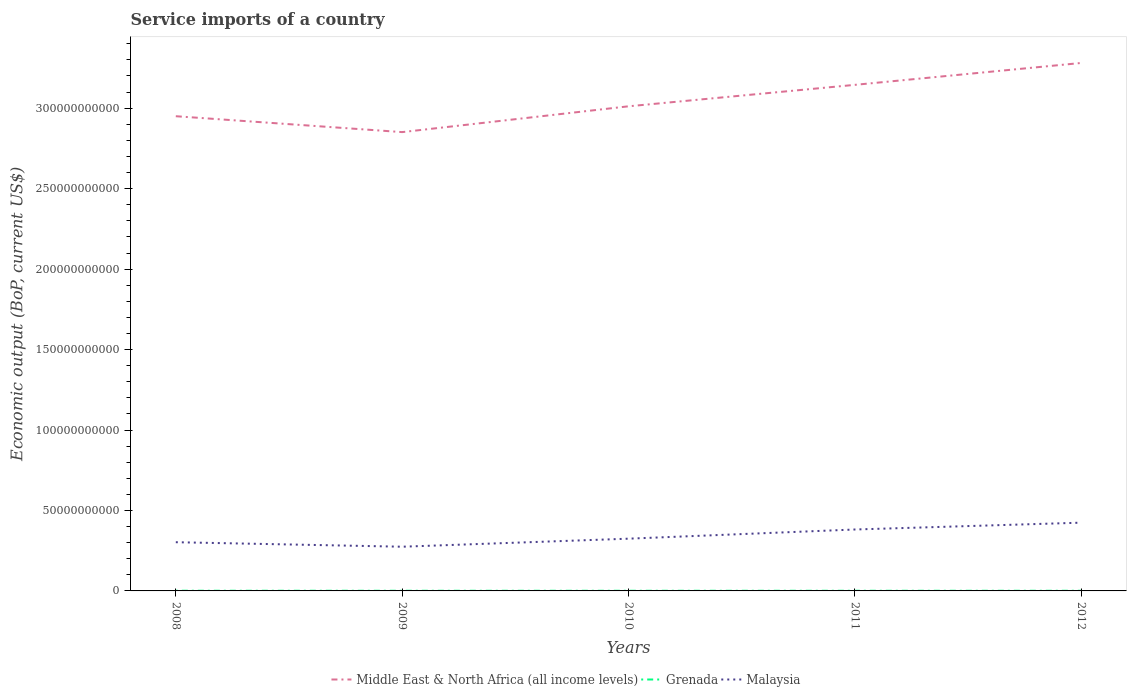Does the line corresponding to Malaysia intersect with the line corresponding to Grenada?
Give a very brief answer. No. Across all years, what is the maximum service imports in Grenada?
Offer a very short reply. 9.40e+07. What is the total service imports in Malaysia in the graph?
Offer a terse response. -1.49e+1. What is the difference between the highest and the second highest service imports in Malaysia?
Provide a succinct answer. 1.49e+1. What is the difference between the highest and the lowest service imports in Grenada?
Ensure brevity in your answer.  2. How many lines are there?
Keep it short and to the point. 3. Are the values on the major ticks of Y-axis written in scientific E-notation?
Make the answer very short. No. Does the graph contain any zero values?
Your answer should be very brief. No. Does the graph contain grids?
Provide a succinct answer. No. Where does the legend appear in the graph?
Ensure brevity in your answer.  Bottom center. What is the title of the graph?
Provide a succinct answer. Service imports of a country. Does "Japan" appear as one of the legend labels in the graph?
Offer a very short reply. No. What is the label or title of the Y-axis?
Make the answer very short. Economic output (BoP, current US$). What is the Economic output (BoP, current US$) of Middle East & North Africa (all income levels) in 2008?
Give a very brief answer. 2.95e+11. What is the Economic output (BoP, current US$) in Grenada in 2008?
Keep it short and to the point. 1.13e+08. What is the Economic output (BoP, current US$) of Malaysia in 2008?
Your answer should be compact. 3.03e+1. What is the Economic output (BoP, current US$) in Middle East & North Africa (all income levels) in 2009?
Ensure brevity in your answer.  2.85e+11. What is the Economic output (BoP, current US$) in Grenada in 2009?
Your response must be concise. 9.81e+07. What is the Economic output (BoP, current US$) in Malaysia in 2009?
Your answer should be compact. 2.75e+1. What is the Economic output (BoP, current US$) in Middle East & North Africa (all income levels) in 2010?
Give a very brief answer. 3.01e+11. What is the Economic output (BoP, current US$) in Grenada in 2010?
Provide a succinct answer. 9.40e+07. What is the Economic output (BoP, current US$) of Malaysia in 2010?
Keep it short and to the point. 3.25e+1. What is the Economic output (BoP, current US$) in Middle East & North Africa (all income levels) in 2011?
Offer a terse response. 3.15e+11. What is the Economic output (BoP, current US$) in Grenada in 2011?
Provide a succinct answer. 1.00e+08. What is the Economic output (BoP, current US$) in Malaysia in 2011?
Keep it short and to the point. 3.82e+1. What is the Economic output (BoP, current US$) of Middle East & North Africa (all income levels) in 2012?
Ensure brevity in your answer.  3.28e+11. What is the Economic output (BoP, current US$) in Grenada in 2012?
Your answer should be compact. 9.54e+07. What is the Economic output (BoP, current US$) of Malaysia in 2012?
Give a very brief answer. 4.24e+1. Across all years, what is the maximum Economic output (BoP, current US$) of Middle East & North Africa (all income levels)?
Your answer should be very brief. 3.28e+11. Across all years, what is the maximum Economic output (BoP, current US$) of Grenada?
Your answer should be compact. 1.13e+08. Across all years, what is the maximum Economic output (BoP, current US$) in Malaysia?
Your answer should be compact. 4.24e+1. Across all years, what is the minimum Economic output (BoP, current US$) in Middle East & North Africa (all income levels)?
Your answer should be very brief. 2.85e+11. Across all years, what is the minimum Economic output (BoP, current US$) in Grenada?
Provide a succinct answer. 9.40e+07. Across all years, what is the minimum Economic output (BoP, current US$) of Malaysia?
Offer a terse response. 2.75e+1. What is the total Economic output (BoP, current US$) in Middle East & North Africa (all income levels) in the graph?
Give a very brief answer. 1.52e+12. What is the total Economic output (BoP, current US$) in Grenada in the graph?
Offer a terse response. 5.01e+08. What is the total Economic output (BoP, current US$) of Malaysia in the graph?
Your response must be concise. 1.71e+11. What is the difference between the Economic output (BoP, current US$) of Middle East & North Africa (all income levels) in 2008 and that in 2009?
Give a very brief answer. 9.87e+09. What is the difference between the Economic output (BoP, current US$) of Grenada in 2008 and that in 2009?
Offer a very short reply. 1.49e+07. What is the difference between the Economic output (BoP, current US$) in Malaysia in 2008 and that in 2009?
Give a very brief answer. 2.80e+09. What is the difference between the Economic output (BoP, current US$) in Middle East & North Africa (all income levels) in 2008 and that in 2010?
Ensure brevity in your answer.  -6.16e+09. What is the difference between the Economic output (BoP, current US$) of Grenada in 2008 and that in 2010?
Give a very brief answer. 1.90e+07. What is the difference between the Economic output (BoP, current US$) in Malaysia in 2008 and that in 2010?
Your answer should be very brief. -2.20e+09. What is the difference between the Economic output (BoP, current US$) in Middle East & North Africa (all income levels) in 2008 and that in 2011?
Ensure brevity in your answer.  -1.95e+1. What is the difference between the Economic output (BoP, current US$) in Grenada in 2008 and that in 2011?
Provide a short and direct response. 1.28e+07. What is the difference between the Economic output (BoP, current US$) of Malaysia in 2008 and that in 2011?
Make the answer very short. -7.90e+09. What is the difference between the Economic output (BoP, current US$) in Middle East & North Africa (all income levels) in 2008 and that in 2012?
Make the answer very short. -3.31e+1. What is the difference between the Economic output (BoP, current US$) of Grenada in 2008 and that in 2012?
Provide a succinct answer. 1.76e+07. What is the difference between the Economic output (BoP, current US$) of Malaysia in 2008 and that in 2012?
Keep it short and to the point. -1.21e+1. What is the difference between the Economic output (BoP, current US$) of Middle East & North Africa (all income levels) in 2009 and that in 2010?
Ensure brevity in your answer.  -1.60e+1. What is the difference between the Economic output (BoP, current US$) of Grenada in 2009 and that in 2010?
Provide a succinct answer. 4.11e+06. What is the difference between the Economic output (BoP, current US$) of Malaysia in 2009 and that in 2010?
Your answer should be compact. -5.00e+09. What is the difference between the Economic output (BoP, current US$) of Middle East & North Africa (all income levels) in 2009 and that in 2011?
Make the answer very short. -2.94e+1. What is the difference between the Economic output (BoP, current US$) of Grenada in 2009 and that in 2011?
Give a very brief answer. -2.10e+06. What is the difference between the Economic output (BoP, current US$) in Malaysia in 2009 and that in 2011?
Your answer should be compact. -1.07e+1. What is the difference between the Economic output (BoP, current US$) in Middle East & North Africa (all income levels) in 2009 and that in 2012?
Your answer should be very brief. -4.30e+1. What is the difference between the Economic output (BoP, current US$) of Grenada in 2009 and that in 2012?
Provide a short and direct response. 2.73e+06. What is the difference between the Economic output (BoP, current US$) of Malaysia in 2009 and that in 2012?
Ensure brevity in your answer.  -1.49e+1. What is the difference between the Economic output (BoP, current US$) of Middle East & North Africa (all income levels) in 2010 and that in 2011?
Provide a succinct answer. -1.33e+1. What is the difference between the Economic output (BoP, current US$) in Grenada in 2010 and that in 2011?
Offer a terse response. -6.20e+06. What is the difference between the Economic output (BoP, current US$) of Malaysia in 2010 and that in 2011?
Provide a short and direct response. -5.70e+09. What is the difference between the Economic output (BoP, current US$) of Middle East & North Africa (all income levels) in 2010 and that in 2012?
Provide a short and direct response. -2.69e+1. What is the difference between the Economic output (BoP, current US$) of Grenada in 2010 and that in 2012?
Ensure brevity in your answer.  -1.37e+06. What is the difference between the Economic output (BoP, current US$) of Malaysia in 2010 and that in 2012?
Keep it short and to the point. -9.95e+09. What is the difference between the Economic output (BoP, current US$) in Middle East & North Africa (all income levels) in 2011 and that in 2012?
Give a very brief answer. -1.36e+1. What is the difference between the Economic output (BoP, current US$) of Grenada in 2011 and that in 2012?
Provide a short and direct response. 4.83e+06. What is the difference between the Economic output (BoP, current US$) of Malaysia in 2011 and that in 2012?
Your answer should be very brief. -4.25e+09. What is the difference between the Economic output (BoP, current US$) of Middle East & North Africa (all income levels) in 2008 and the Economic output (BoP, current US$) of Grenada in 2009?
Ensure brevity in your answer.  2.95e+11. What is the difference between the Economic output (BoP, current US$) of Middle East & North Africa (all income levels) in 2008 and the Economic output (BoP, current US$) of Malaysia in 2009?
Give a very brief answer. 2.68e+11. What is the difference between the Economic output (BoP, current US$) in Grenada in 2008 and the Economic output (BoP, current US$) in Malaysia in 2009?
Your response must be concise. -2.74e+1. What is the difference between the Economic output (BoP, current US$) of Middle East & North Africa (all income levels) in 2008 and the Economic output (BoP, current US$) of Grenada in 2010?
Make the answer very short. 2.95e+11. What is the difference between the Economic output (BoP, current US$) in Middle East & North Africa (all income levels) in 2008 and the Economic output (BoP, current US$) in Malaysia in 2010?
Your response must be concise. 2.63e+11. What is the difference between the Economic output (BoP, current US$) of Grenada in 2008 and the Economic output (BoP, current US$) of Malaysia in 2010?
Ensure brevity in your answer.  -3.24e+1. What is the difference between the Economic output (BoP, current US$) of Middle East & North Africa (all income levels) in 2008 and the Economic output (BoP, current US$) of Grenada in 2011?
Provide a short and direct response. 2.95e+11. What is the difference between the Economic output (BoP, current US$) of Middle East & North Africa (all income levels) in 2008 and the Economic output (BoP, current US$) of Malaysia in 2011?
Your answer should be very brief. 2.57e+11. What is the difference between the Economic output (BoP, current US$) in Grenada in 2008 and the Economic output (BoP, current US$) in Malaysia in 2011?
Your response must be concise. -3.81e+1. What is the difference between the Economic output (BoP, current US$) of Middle East & North Africa (all income levels) in 2008 and the Economic output (BoP, current US$) of Grenada in 2012?
Make the answer very short. 2.95e+11. What is the difference between the Economic output (BoP, current US$) of Middle East & North Africa (all income levels) in 2008 and the Economic output (BoP, current US$) of Malaysia in 2012?
Your answer should be compact. 2.53e+11. What is the difference between the Economic output (BoP, current US$) of Grenada in 2008 and the Economic output (BoP, current US$) of Malaysia in 2012?
Give a very brief answer. -4.23e+1. What is the difference between the Economic output (BoP, current US$) of Middle East & North Africa (all income levels) in 2009 and the Economic output (BoP, current US$) of Grenada in 2010?
Your answer should be very brief. 2.85e+11. What is the difference between the Economic output (BoP, current US$) in Middle East & North Africa (all income levels) in 2009 and the Economic output (BoP, current US$) in Malaysia in 2010?
Keep it short and to the point. 2.53e+11. What is the difference between the Economic output (BoP, current US$) of Grenada in 2009 and the Economic output (BoP, current US$) of Malaysia in 2010?
Keep it short and to the point. -3.24e+1. What is the difference between the Economic output (BoP, current US$) of Middle East & North Africa (all income levels) in 2009 and the Economic output (BoP, current US$) of Grenada in 2011?
Offer a very short reply. 2.85e+11. What is the difference between the Economic output (BoP, current US$) of Middle East & North Africa (all income levels) in 2009 and the Economic output (BoP, current US$) of Malaysia in 2011?
Your answer should be compact. 2.47e+11. What is the difference between the Economic output (BoP, current US$) in Grenada in 2009 and the Economic output (BoP, current US$) in Malaysia in 2011?
Your response must be concise. -3.81e+1. What is the difference between the Economic output (BoP, current US$) in Middle East & North Africa (all income levels) in 2009 and the Economic output (BoP, current US$) in Grenada in 2012?
Provide a succinct answer. 2.85e+11. What is the difference between the Economic output (BoP, current US$) of Middle East & North Africa (all income levels) in 2009 and the Economic output (BoP, current US$) of Malaysia in 2012?
Your response must be concise. 2.43e+11. What is the difference between the Economic output (BoP, current US$) of Grenada in 2009 and the Economic output (BoP, current US$) of Malaysia in 2012?
Your answer should be very brief. -4.23e+1. What is the difference between the Economic output (BoP, current US$) in Middle East & North Africa (all income levels) in 2010 and the Economic output (BoP, current US$) in Grenada in 2011?
Your answer should be very brief. 3.01e+11. What is the difference between the Economic output (BoP, current US$) in Middle East & North Africa (all income levels) in 2010 and the Economic output (BoP, current US$) in Malaysia in 2011?
Ensure brevity in your answer.  2.63e+11. What is the difference between the Economic output (BoP, current US$) of Grenada in 2010 and the Economic output (BoP, current US$) of Malaysia in 2011?
Keep it short and to the point. -3.81e+1. What is the difference between the Economic output (BoP, current US$) of Middle East & North Africa (all income levels) in 2010 and the Economic output (BoP, current US$) of Grenada in 2012?
Your answer should be very brief. 3.01e+11. What is the difference between the Economic output (BoP, current US$) of Middle East & North Africa (all income levels) in 2010 and the Economic output (BoP, current US$) of Malaysia in 2012?
Give a very brief answer. 2.59e+11. What is the difference between the Economic output (BoP, current US$) in Grenada in 2010 and the Economic output (BoP, current US$) in Malaysia in 2012?
Ensure brevity in your answer.  -4.23e+1. What is the difference between the Economic output (BoP, current US$) in Middle East & North Africa (all income levels) in 2011 and the Economic output (BoP, current US$) in Grenada in 2012?
Give a very brief answer. 3.14e+11. What is the difference between the Economic output (BoP, current US$) in Middle East & North Africa (all income levels) in 2011 and the Economic output (BoP, current US$) in Malaysia in 2012?
Your answer should be very brief. 2.72e+11. What is the difference between the Economic output (BoP, current US$) of Grenada in 2011 and the Economic output (BoP, current US$) of Malaysia in 2012?
Ensure brevity in your answer.  -4.23e+1. What is the average Economic output (BoP, current US$) in Middle East & North Africa (all income levels) per year?
Provide a short and direct response. 3.05e+11. What is the average Economic output (BoP, current US$) in Grenada per year?
Your answer should be very brief. 1.00e+08. What is the average Economic output (BoP, current US$) in Malaysia per year?
Give a very brief answer. 3.42e+1. In the year 2008, what is the difference between the Economic output (BoP, current US$) of Middle East & North Africa (all income levels) and Economic output (BoP, current US$) of Grenada?
Keep it short and to the point. 2.95e+11. In the year 2008, what is the difference between the Economic output (BoP, current US$) in Middle East & North Africa (all income levels) and Economic output (BoP, current US$) in Malaysia?
Your answer should be very brief. 2.65e+11. In the year 2008, what is the difference between the Economic output (BoP, current US$) in Grenada and Economic output (BoP, current US$) in Malaysia?
Offer a very short reply. -3.02e+1. In the year 2009, what is the difference between the Economic output (BoP, current US$) of Middle East & North Africa (all income levels) and Economic output (BoP, current US$) of Grenada?
Your answer should be very brief. 2.85e+11. In the year 2009, what is the difference between the Economic output (BoP, current US$) of Middle East & North Africa (all income levels) and Economic output (BoP, current US$) of Malaysia?
Your answer should be very brief. 2.58e+11. In the year 2009, what is the difference between the Economic output (BoP, current US$) in Grenada and Economic output (BoP, current US$) in Malaysia?
Your answer should be very brief. -2.74e+1. In the year 2010, what is the difference between the Economic output (BoP, current US$) in Middle East & North Africa (all income levels) and Economic output (BoP, current US$) in Grenada?
Make the answer very short. 3.01e+11. In the year 2010, what is the difference between the Economic output (BoP, current US$) of Middle East & North Africa (all income levels) and Economic output (BoP, current US$) of Malaysia?
Give a very brief answer. 2.69e+11. In the year 2010, what is the difference between the Economic output (BoP, current US$) in Grenada and Economic output (BoP, current US$) in Malaysia?
Make the answer very short. -3.24e+1. In the year 2011, what is the difference between the Economic output (BoP, current US$) in Middle East & North Africa (all income levels) and Economic output (BoP, current US$) in Grenada?
Give a very brief answer. 3.14e+11. In the year 2011, what is the difference between the Economic output (BoP, current US$) of Middle East & North Africa (all income levels) and Economic output (BoP, current US$) of Malaysia?
Your answer should be compact. 2.76e+11. In the year 2011, what is the difference between the Economic output (BoP, current US$) of Grenada and Economic output (BoP, current US$) of Malaysia?
Provide a short and direct response. -3.81e+1. In the year 2012, what is the difference between the Economic output (BoP, current US$) in Middle East & North Africa (all income levels) and Economic output (BoP, current US$) in Grenada?
Your answer should be compact. 3.28e+11. In the year 2012, what is the difference between the Economic output (BoP, current US$) in Middle East & North Africa (all income levels) and Economic output (BoP, current US$) in Malaysia?
Make the answer very short. 2.86e+11. In the year 2012, what is the difference between the Economic output (BoP, current US$) of Grenada and Economic output (BoP, current US$) of Malaysia?
Keep it short and to the point. -4.23e+1. What is the ratio of the Economic output (BoP, current US$) in Middle East & North Africa (all income levels) in 2008 to that in 2009?
Offer a terse response. 1.03. What is the ratio of the Economic output (BoP, current US$) of Grenada in 2008 to that in 2009?
Offer a terse response. 1.15. What is the ratio of the Economic output (BoP, current US$) in Malaysia in 2008 to that in 2009?
Ensure brevity in your answer.  1.1. What is the ratio of the Economic output (BoP, current US$) of Middle East & North Africa (all income levels) in 2008 to that in 2010?
Make the answer very short. 0.98. What is the ratio of the Economic output (BoP, current US$) of Grenada in 2008 to that in 2010?
Ensure brevity in your answer.  1.2. What is the ratio of the Economic output (BoP, current US$) in Malaysia in 2008 to that in 2010?
Your answer should be very brief. 0.93. What is the ratio of the Economic output (BoP, current US$) of Middle East & North Africa (all income levels) in 2008 to that in 2011?
Your response must be concise. 0.94. What is the ratio of the Economic output (BoP, current US$) of Grenada in 2008 to that in 2011?
Give a very brief answer. 1.13. What is the ratio of the Economic output (BoP, current US$) in Malaysia in 2008 to that in 2011?
Keep it short and to the point. 0.79. What is the ratio of the Economic output (BoP, current US$) in Middle East & North Africa (all income levels) in 2008 to that in 2012?
Offer a very short reply. 0.9. What is the ratio of the Economic output (BoP, current US$) in Grenada in 2008 to that in 2012?
Offer a very short reply. 1.18. What is the ratio of the Economic output (BoP, current US$) of Malaysia in 2008 to that in 2012?
Provide a short and direct response. 0.71. What is the ratio of the Economic output (BoP, current US$) in Middle East & North Africa (all income levels) in 2009 to that in 2010?
Your response must be concise. 0.95. What is the ratio of the Economic output (BoP, current US$) of Grenada in 2009 to that in 2010?
Offer a terse response. 1.04. What is the ratio of the Economic output (BoP, current US$) of Malaysia in 2009 to that in 2010?
Offer a very short reply. 0.85. What is the ratio of the Economic output (BoP, current US$) of Middle East & North Africa (all income levels) in 2009 to that in 2011?
Your answer should be very brief. 0.91. What is the ratio of the Economic output (BoP, current US$) in Grenada in 2009 to that in 2011?
Give a very brief answer. 0.98. What is the ratio of the Economic output (BoP, current US$) in Malaysia in 2009 to that in 2011?
Ensure brevity in your answer.  0.72. What is the ratio of the Economic output (BoP, current US$) in Middle East & North Africa (all income levels) in 2009 to that in 2012?
Keep it short and to the point. 0.87. What is the ratio of the Economic output (BoP, current US$) of Grenada in 2009 to that in 2012?
Offer a terse response. 1.03. What is the ratio of the Economic output (BoP, current US$) in Malaysia in 2009 to that in 2012?
Make the answer very short. 0.65. What is the ratio of the Economic output (BoP, current US$) in Middle East & North Africa (all income levels) in 2010 to that in 2011?
Your answer should be very brief. 0.96. What is the ratio of the Economic output (BoP, current US$) in Grenada in 2010 to that in 2011?
Offer a terse response. 0.94. What is the ratio of the Economic output (BoP, current US$) of Malaysia in 2010 to that in 2011?
Make the answer very short. 0.85. What is the ratio of the Economic output (BoP, current US$) in Middle East & North Africa (all income levels) in 2010 to that in 2012?
Make the answer very short. 0.92. What is the ratio of the Economic output (BoP, current US$) in Grenada in 2010 to that in 2012?
Offer a terse response. 0.99. What is the ratio of the Economic output (BoP, current US$) of Malaysia in 2010 to that in 2012?
Keep it short and to the point. 0.77. What is the ratio of the Economic output (BoP, current US$) of Middle East & North Africa (all income levels) in 2011 to that in 2012?
Provide a short and direct response. 0.96. What is the ratio of the Economic output (BoP, current US$) of Grenada in 2011 to that in 2012?
Give a very brief answer. 1.05. What is the ratio of the Economic output (BoP, current US$) of Malaysia in 2011 to that in 2012?
Give a very brief answer. 0.9. What is the difference between the highest and the second highest Economic output (BoP, current US$) in Middle East & North Africa (all income levels)?
Keep it short and to the point. 1.36e+1. What is the difference between the highest and the second highest Economic output (BoP, current US$) in Grenada?
Offer a very short reply. 1.28e+07. What is the difference between the highest and the second highest Economic output (BoP, current US$) of Malaysia?
Give a very brief answer. 4.25e+09. What is the difference between the highest and the lowest Economic output (BoP, current US$) in Middle East & North Africa (all income levels)?
Provide a succinct answer. 4.30e+1. What is the difference between the highest and the lowest Economic output (BoP, current US$) of Grenada?
Keep it short and to the point. 1.90e+07. What is the difference between the highest and the lowest Economic output (BoP, current US$) in Malaysia?
Offer a terse response. 1.49e+1. 